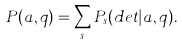Convert formula to latex. <formula><loc_0><loc_0><loc_500><loc_500>P ( a , q ) = \sum _ { s } P _ { s } ( d e t | a , q ) .</formula> 